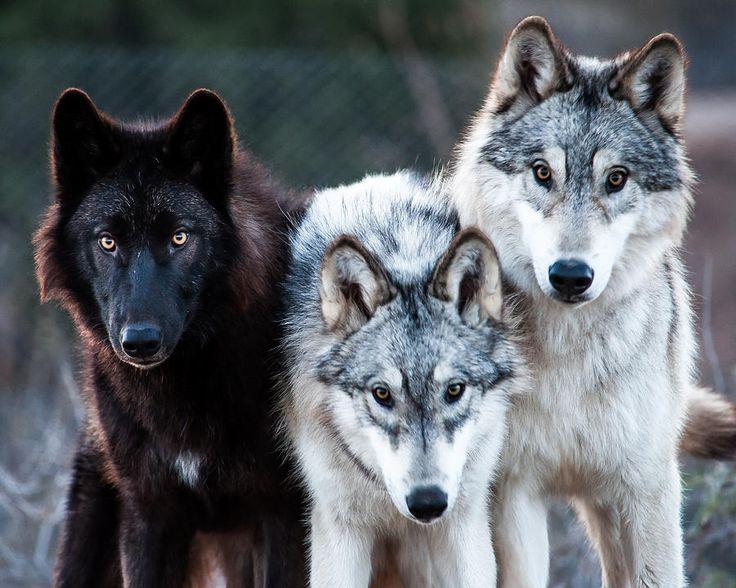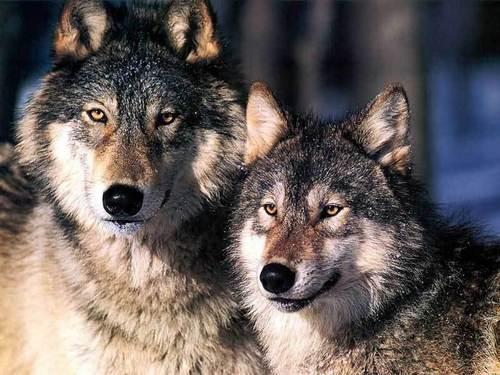The first image is the image on the left, the second image is the image on the right. For the images displayed, is the sentence "The image on the left contains one more wolf than the image on the right." factually correct? Answer yes or no. Yes. The first image is the image on the left, the second image is the image on the right. For the images displayed, is the sentence "There are at least three wolves." factually correct? Answer yes or no. Yes. 